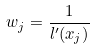<formula> <loc_0><loc_0><loc_500><loc_500>w _ { j } = \frac { 1 } { l ^ { \prime } ( x _ { j } ) }</formula> 